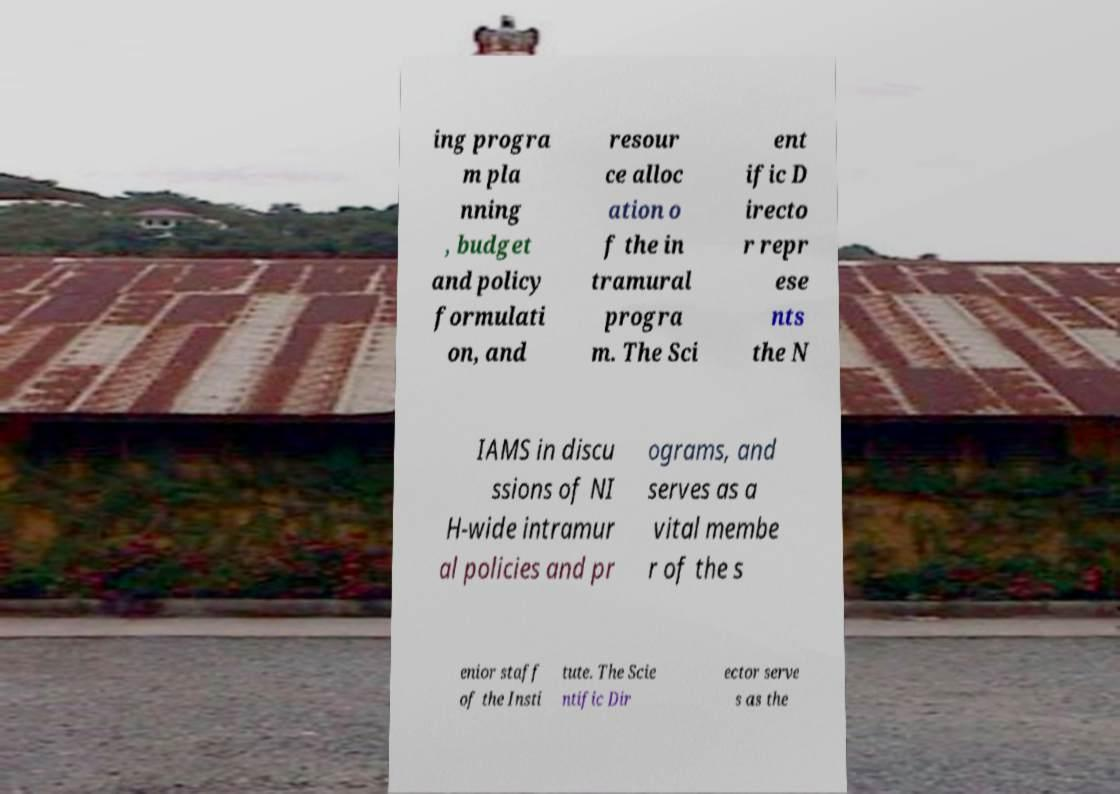Could you assist in decoding the text presented in this image and type it out clearly? ing progra m pla nning , budget and policy formulati on, and resour ce alloc ation o f the in tramural progra m. The Sci ent ific D irecto r repr ese nts the N IAMS in discu ssions of NI H-wide intramur al policies and pr ograms, and serves as a vital membe r of the s enior staff of the Insti tute. The Scie ntific Dir ector serve s as the 